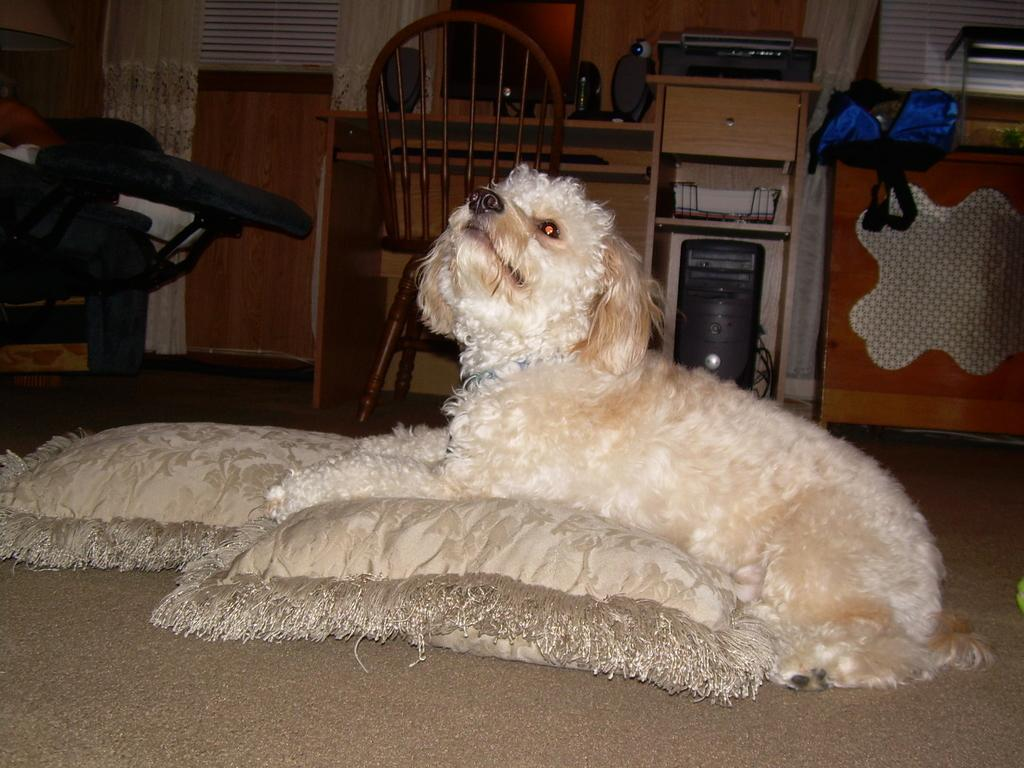What type of animal is in the image? There is a dog in the image. What is the dog sitting on? The dog is sitting on a pillow. What type of furniture is present in the image? There is a desktop, a chair, and a table in the image. What type of print can be seen on the dog's fur in the image? There is no print visible on the dog's fur in the image. Can you see the dog running in the image? The dog is sitting on a pillow and not running in the image. 